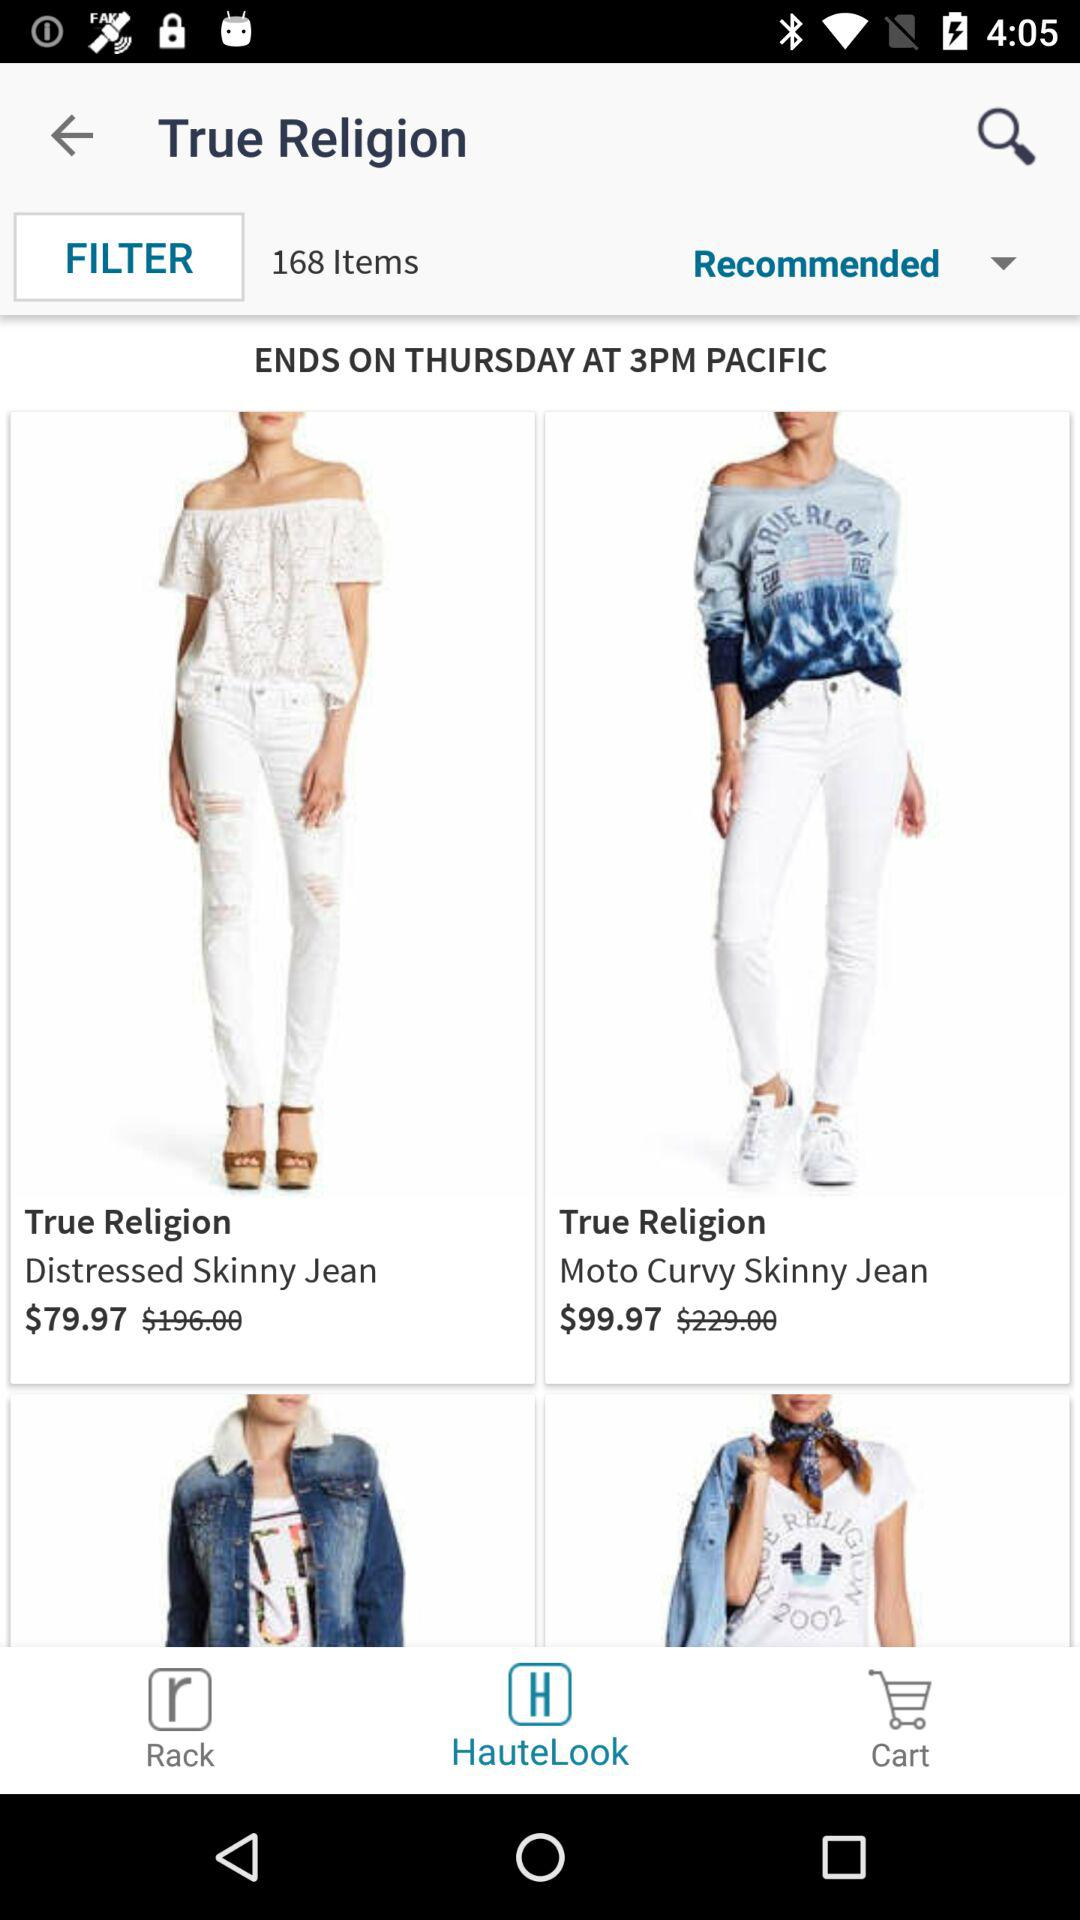What is the original price of "Distressed Skinny Jean"? The price is $79.97. 